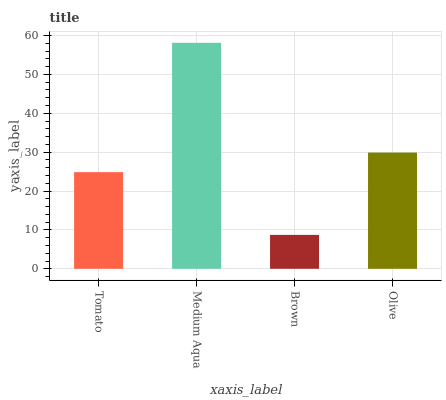Is Brown the minimum?
Answer yes or no. Yes. Is Medium Aqua the maximum?
Answer yes or no. Yes. Is Medium Aqua the minimum?
Answer yes or no. No. Is Brown the maximum?
Answer yes or no. No. Is Medium Aqua greater than Brown?
Answer yes or no. Yes. Is Brown less than Medium Aqua?
Answer yes or no. Yes. Is Brown greater than Medium Aqua?
Answer yes or no. No. Is Medium Aqua less than Brown?
Answer yes or no. No. Is Olive the high median?
Answer yes or no. Yes. Is Tomato the low median?
Answer yes or no. Yes. Is Brown the high median?
Answer yes or no. No. Is Olive the low median?
Answer yes or no. No. 